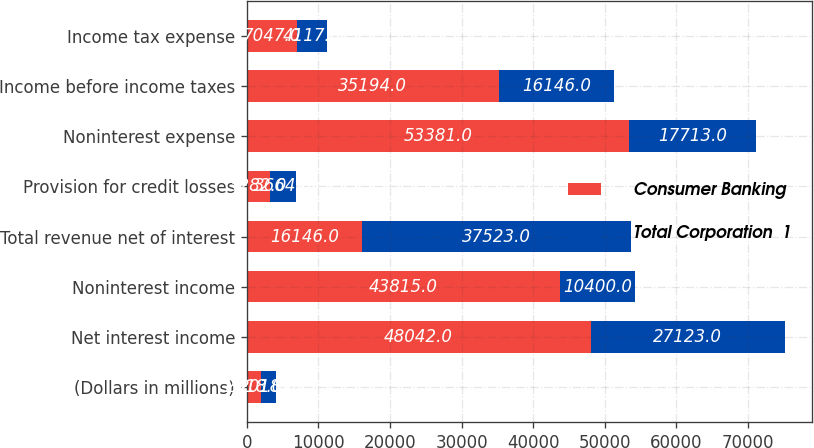Convert chart. <chart><loc_0><loc_0><loc_500><loc_500><stacked_bar_chart><ecel><fcel>(Dollars in millions)<fcel>Net interest income<fcel>Noninterest income<fcel>Total revenue net of interest<fcel>Provision for credit losses<fcel>Noninterest expense<fcel>Income before income taxes<fcel>Income tax expense<nl><fcel>Consumer Banking<fcel>2018<fcel>48042<fcel>43815<fcel>16146<fcel>3282<fcel>53381<fcel>35194<fcel>7047<nl><fcel>Total Corporation  1<fcel>2018<fcel>27123<fcel>10400<fcel>37523<fcel>3664<fcel>17713<fcel>16146<fcel>4117<nl></chart> 